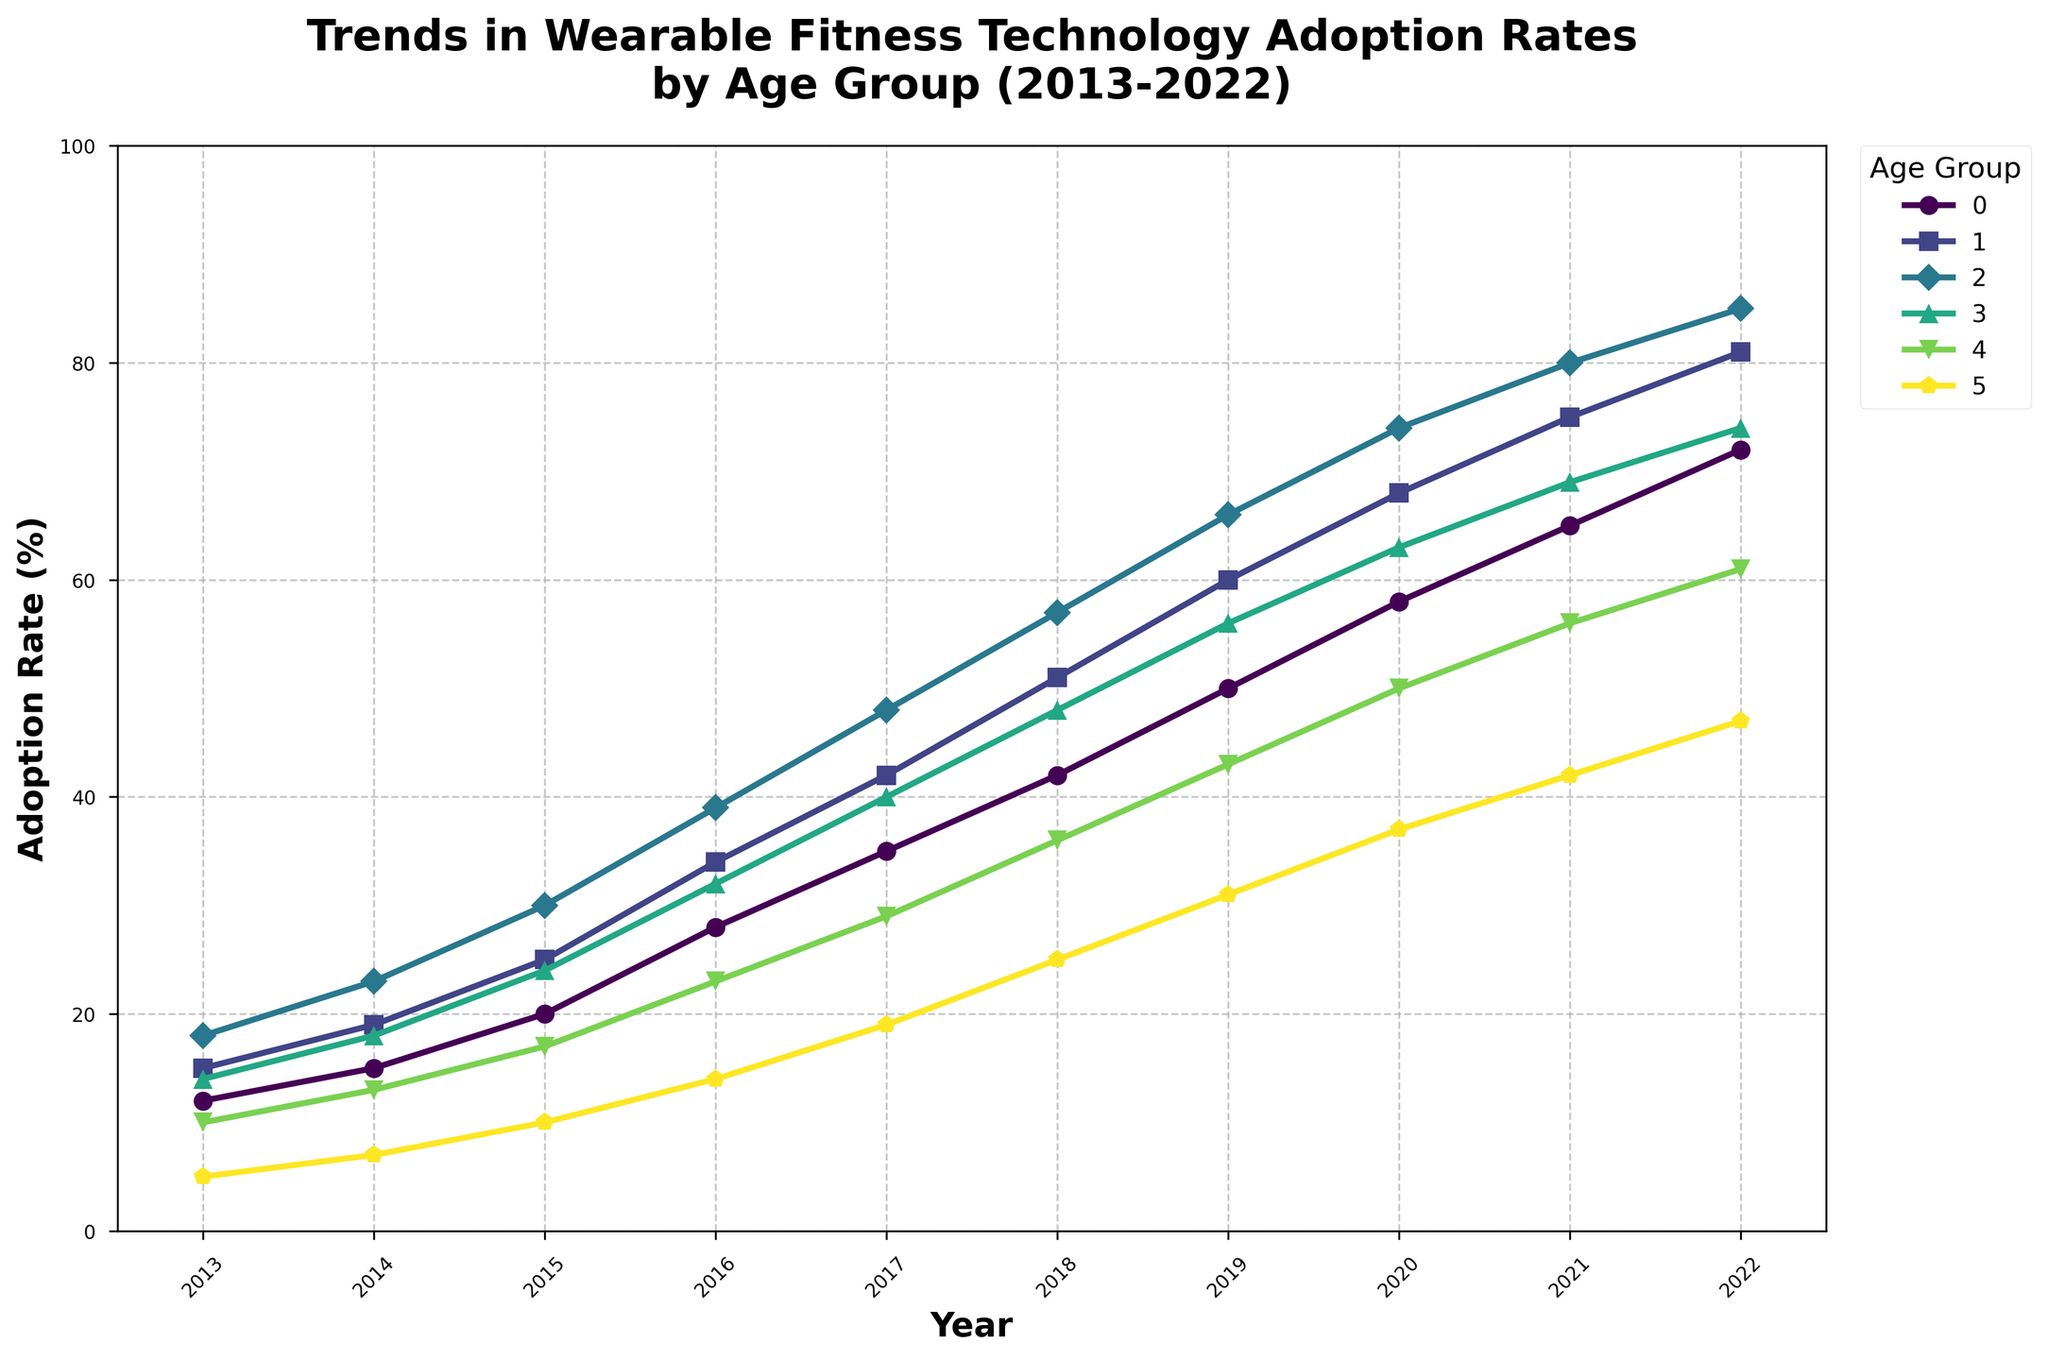Which age group had the highest adoption rate in 2022? By looking at the figure, identify the line that is at the highest point in 2022. The highest line corresponds to the age group 35-44, which is at 85%.
Answer: Age group 35-44 Which age group experienced the most significant increase in adoption rates between 2013 and 2022? To find this, calculate the difference in adoption rates for each age group between 2013 and 2022. The largest difference is for the age group 35-44, which increased from 18% to 85%, resulting in an increase of 67%.
Answer: Age group 35-44 What is the average adoption rate for the age group 25-34 between 2013 and 2022? Sum the adoption rates for the age group 25-34 across all years and divide by the number of years (10). The sum is 420, and the average is 420 / 10 = 42%.
Answer: 42% Which age groups saw their adoption rates surpass 60% by 2020? Looking at the year 2020, find the lines that are above the 60% mark. The age groups 18-24, 25-34, and 35-44 had adoption rates of 58%, 68%, and 74%, respectively. So, the correct answer is 25-34 and 35-44.
Answer: 25-34, 35-44 Between which two consecutive years did the age group 45-54 see the highest increase in adoption rates? Examine the increments between each pair of consecutive years. The most considerable increase for 45-54 is between 2014 and 2015, where the rate increases from 18% to 24%, an increase of 6%.
Answer: 2014 and 2015 Which age group is represented by the line with the steepest climb between 2017 and 2018? Identify the line with the steepest slope between these years. The age group 35-44 increases from 48% to 57%, a 9% difference.
Answer: Age group 35-44 What is the difference in adoption rates for the 55-64 age group between 2013 and 2020? Find the adoption rates for 2013 and 2020, which are 10% and 50%, respectively. The difference is 50% - 10% = 40%.
Answer: 40% Which age group had the least adoption rate in 2022, and what was the percentage? Find the line at the lowest point in 2022. This corresponds to the age group 65+ with 47%.
Answer: Age group 65+, 47% What is the overall trend for all age groups from 2013 to 2022? By examining the direction of the lines for all age groups, it's clear that the adoption rates for wearable fitness technology are increasing over time.
Answer: Increasing From 2016 to 2018, which age group had the slowest rate of increase in adoption rates? Calculate the increase for each age group between these years. The slowest increase is for the age group 65+, from 14% to 25%, a difference of 11%.
Answer: Age group 65+ 